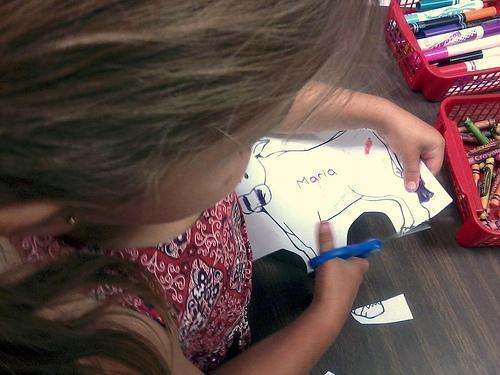How many people are pictured?
Give a very brief answer. 1. How many red baskets are pictured?
Give a very brief answer. 2. 